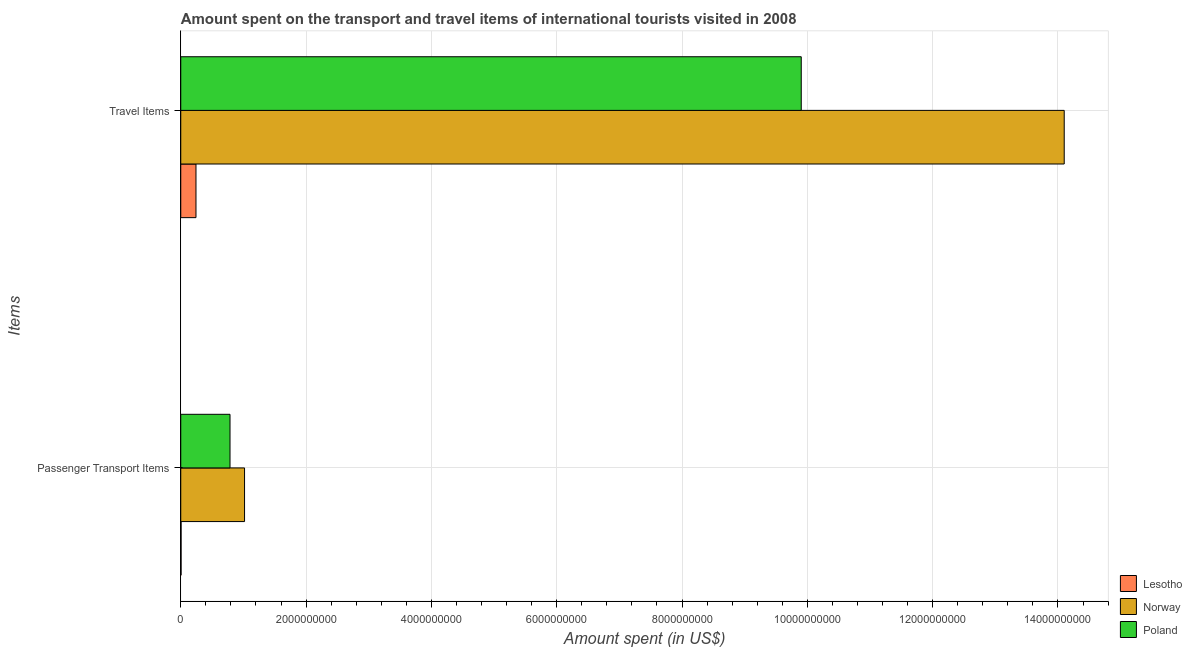How many different coloured bars are there?
Make the answer very short. 3. How many groups of bars are there?
Your answer should be compact. 2. Are the number of bars per tick equal to the number of legend labels?
Provide a short and direct response. Yes. What is the label of the 1st group of bars from the top?
Ensure brevity in your answer.  Travel Items. What is the amount spent in travel items in Norway?
Offer a very short reply. 1.41e+1. Across all countries, what is the maximum amount spent in travel items?
Offer a terse response. 1.41e+1. Across all countries, what is the minimum amount spent on passenger transport items?
Keep it short and to the point. 5.00e+06. In which country was the amount spent on passenger transport items maximum?
Provide a succinct answer. Norway. In which country was the amount spent in travel items minimum?
Ensure brevity in your answer.  Lesotho. What is the total amount spent on passenger transport items in the graph?
Your response must be concise. 1.81e+09. What is the difference between the amount spent on passenger transport items in Norway and that in Poland?
Make the answer very short. 2.32e+08. What is the difference between the amount spent in travel items in Norway and the amount spent on passenger transport items in Lesotho?
Your answer should be compact. 1.41e+1. What is the average amount spent in travel items per country?
Provide a succinct answer. 8.08e+09. What is the difference between the amount spent on passenger transport items and amount spent in travel items in Norway?
Keep it short and to the point. -1.31e+1. What is the ratio of the amount spent on passenger transport items in Norway to that in Poland?
Keep it short and to the point. 1.3. In how many countries, is the amount spent in travel items greater than the average amount spent in travel items taken over all countries?
Your answer should be compact. 2. What does the 1st bar from the bottom in Passenger Transport Items represents?
Provide a succinct answer. Lesotho. How many countries are there in the graph?
Offer a terse response. 3. Are the values on the major ticks of X-axis written in scientific E-notation?
Offer a very short reply. No. Does the graph contain any zero values?
Your answer should be compact. No. Does the graph contain grids?
Make the answer very short. Yes. How many legend labels are there?
Your response must be concise. 3. What is the title of the graph?
Offer a terse response. Amount spent on the transport and travel items of international tourists visited in 2008. Does "Iraq" appear as one of the legend labels in the graph?
Give a very brief answer. No. What is the label or title of the X-axis?
Provide a short and direct response. Amount spent (in US$). What is the label or title of the Y-axis?
Offer a very short reply. Items. What is the Amount spent (in US$) of Lesotho in Passenger Transport Items?
Make the answer very short. 5.00e+06. What is the Amount spent (in US$) in Norway in Passenger Transport Items?
Keep it short and to the point. 1.02e+09. What is the Amount spent (in US$) in Poland in Passenger Transport Items?
Provide a succinct answer. 7.86e+08. What is the Amount spent (in US$) of Lesotho in Travel Items?
Your response must be concise. 2.43e+08. What is the Amount spent (in US$) of Norway in Travel Items?
Provide a succinct answer. 1.41e+1. What is the Amount spent (in US$) of Poland in Travel Items?
Your answer should be compact. 9.90e+09. Across all Items, what is the maximum Amount spent (in US$) of Lesotho?
Keep it short and to the point. 2.43e+08. Across all Items, what is the maximum Amount spent (in US$) of Norway?
Ensure brevity in your answer.  1.41e+1. Across all Items, what is the maximum Amount spent (in US$) in Poland?
Offer a terse response. 9.90e+09. Across all Items, what is the minimum Amount spent (in US$) of Norway?
Your answer should be very brief. 1.02e+09. Across all Items, what is the minimum Amount spent (in US$) of Poland?
Keep it short and to the point. 7.86e+08. What is the total Amount spent (in US$) in Lesotho in the graph?
Provide a short and direct response. 2.48e+08. What is the total Amount spent (in US$) of Norway in the graph?
Your answer should be compact. 1.51e+1. What is the total Amount spent (in US$) of Poland in the graph?
Keep it short and to the point. 1.07e+1. What is the difference between the Amount spent (in US$) of Lesotho in Passenger Transport Items and that in Travel Items?
Give a very brief answer. -2.38e+08. What is the difference between the Amount spent (in US$) in Norway in Passenger Transport Items and that in Travel Items?
Ensure brevity in your answer.  -1.31e+1. What is the difference between the Amount spent (in US$) in Poland in Passenger Transport Items and that in Travel Items?
Ensure brevity in your answer.  -9.12e+09. What is the difference between the Amount spent (in US$) of Lesotho in Passenger Transport Items and the Amount spent (in US$) of Norway in Travel Items?
Ensure brevity in your answer.  -1.41e+1. What is the difference between the Amount spent (in US$) of Lesotho in Passenger Transport Items and the Amount spent (in US$) of Poland in Travel Items?
Make the answer very short. -9.90e+09. What is the difference between the Amount spent (in US$) in Norway in Passenger Transport Items and the Amount spent (in US$) in Poland in Travel Items?
Provide a short and direct response. -8.88e+09. What is the average Amount spent (in US$) in Lesotho per Items?
Provide a short and direct response. 1.24e+08. What is the average Amount spent (in US$) in Norway per Items?
Provide a succinct answer. 7.56e+09. What is the average Amount spent (in US$) in Poland per Items?
Your answer should be compact. 5.34e+09. What is the difference between the Amount spent (in US$) of Lesotho and Amount spent (in US$) of Norway in Passenger Transport Items?
Keep it short and to the point. -1.01e+09. What is the difference between the Amount spent (in US$) in Lesotho and Amount spent (in US$) in Poland in Passenger Transport Items?
Your answer should be compact. -7.81e+08. What is the difference between the Amount spent (in US$) of Norway and Amount spent (in US$) of Poland in Passenger Transport Items?
Make the answer very short. 2.32e+08. What is the difference between the Amount spent (in US$) of Lesotho and Amount spent (in US$) of Norway in Travel Items?
Your answer should be very brief. -1.39e+1. What is the difference between the Amount spent (in US$) of Lesotho and Amount spent (in US$) of Poland in Travel Items?
Your response must be concise. -9.66e+09. What is the difference between the Amount spent (in US$) of Norway and Amount spent (in US$) of Poland in Travel Items?
Make the answer very short. 4.20e+09. What is the ratio of the Amount spent (in US$) of Lesotho in Passenger Transport Items to that in Travel Items?
Your answer should be compact. 0.02. What is the ratio of the Amount spent (in US$) of Norway in Passenger Transport Items to that in Travel Items?
Offer a terse response. 0.07. What is the ratio of the Amount spent (in US$) in Poland in Passenger Transport Items to that in Travel Items?
Provide a succinct answer. 0.08. What is the difference between the highest and the second highest Amount spent (in US$) of Lesotho?
Give a very brief answer. 2.38e+08. What is the difference between the highest and the second highest Amount spent (in US$) of Norway?
Ensure brevity in your answer.  1.31e+1. What is the difference between the highest and the second highest Amount spent (in US$) in Poland?
Your answer should be very brief. 9.12e+09. What is the difference between the highest and the lowest Amount spent (in US$) in Lesotho?
Make the answer very short. 2.38e+08. What is the difference between the highest and the lowest Amount spent (in US$) of Norway?
Ensure brevity in your answer.  1.31e+1. What is the difference between the highest and the lowest Amount spent (in US$) in Poland?
Offer a very short reply. 9.12e+09. 